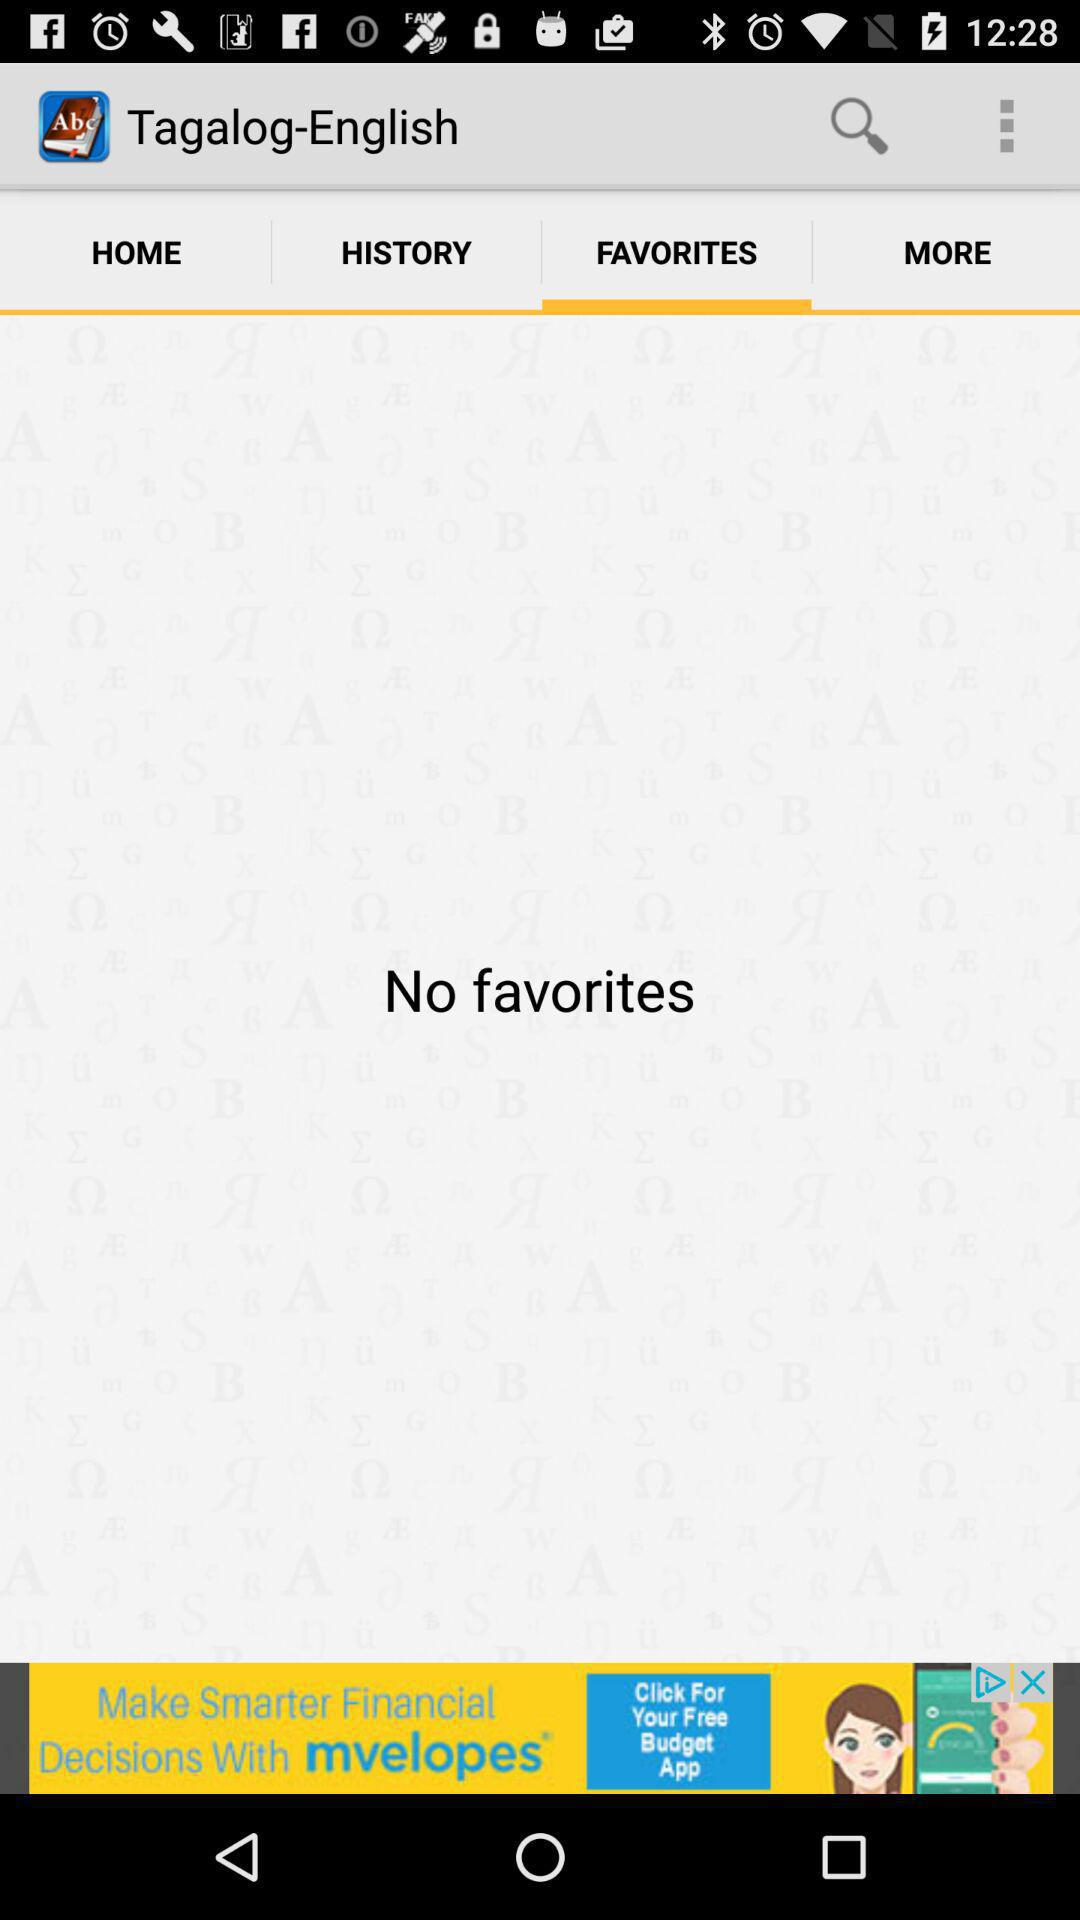What is the name of the application? The name of the application is "Tagalog-English". 